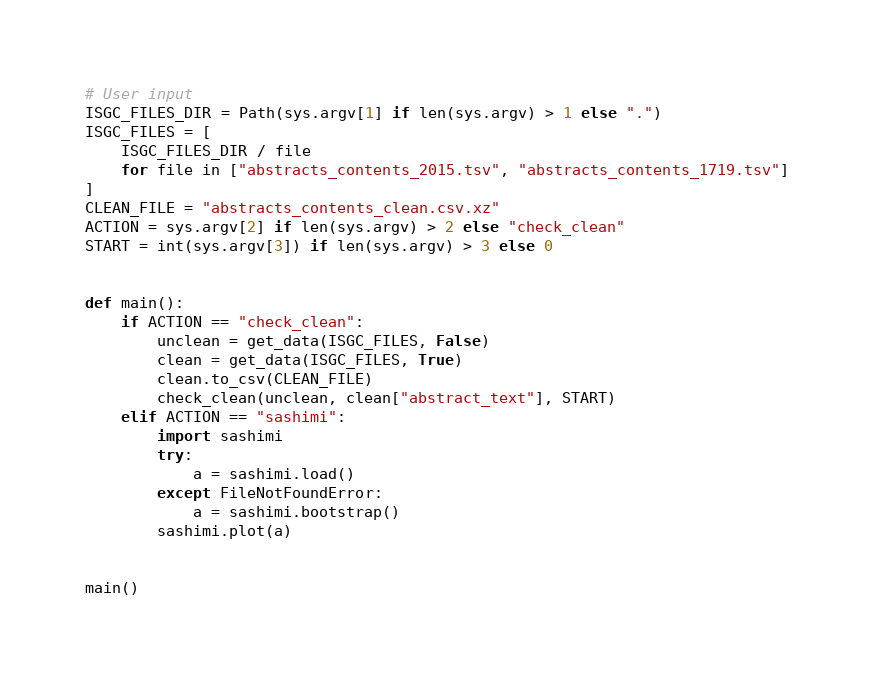<code> <loc_0><loc_0><loc_500><loc_500><_Python_># User input
ISGC_FILES_DIR = Path(sys.argv[1] if len(sys.argv) > 1 else ".")
ISGC_FILES = [
    ISGC_FILES_DIR / file
    for file in ["abstracts_contents_2015.tsv", "abstracts_contents_1719.tsv"]
]
CLEAN_FILE = "abstracts_contents_clean.csv.xz"
ACTION = sys.argv[2] if len(sys.argv) > 2 else "check_clean"
START = int(sys.argv[3]) if len(sys.argv) > 3 else 0


def main():
    if ACTION == "check_clean":
        unclean = get_data(ISGC_FILES, False)
        clean = get_data(ISGC_FILES, True)
        clean.to_csv(CLEAN_FILE)
        check_clean(unclean, clean["abstract_text"], START)
    elif ACTION == "sashimi":
        import sashimi
        try:
            a = sashimi.load()
        except FileNotFoundError:
            a = sashimi.bootstrap()
        sashimi.plot(a)


main()
</code> 